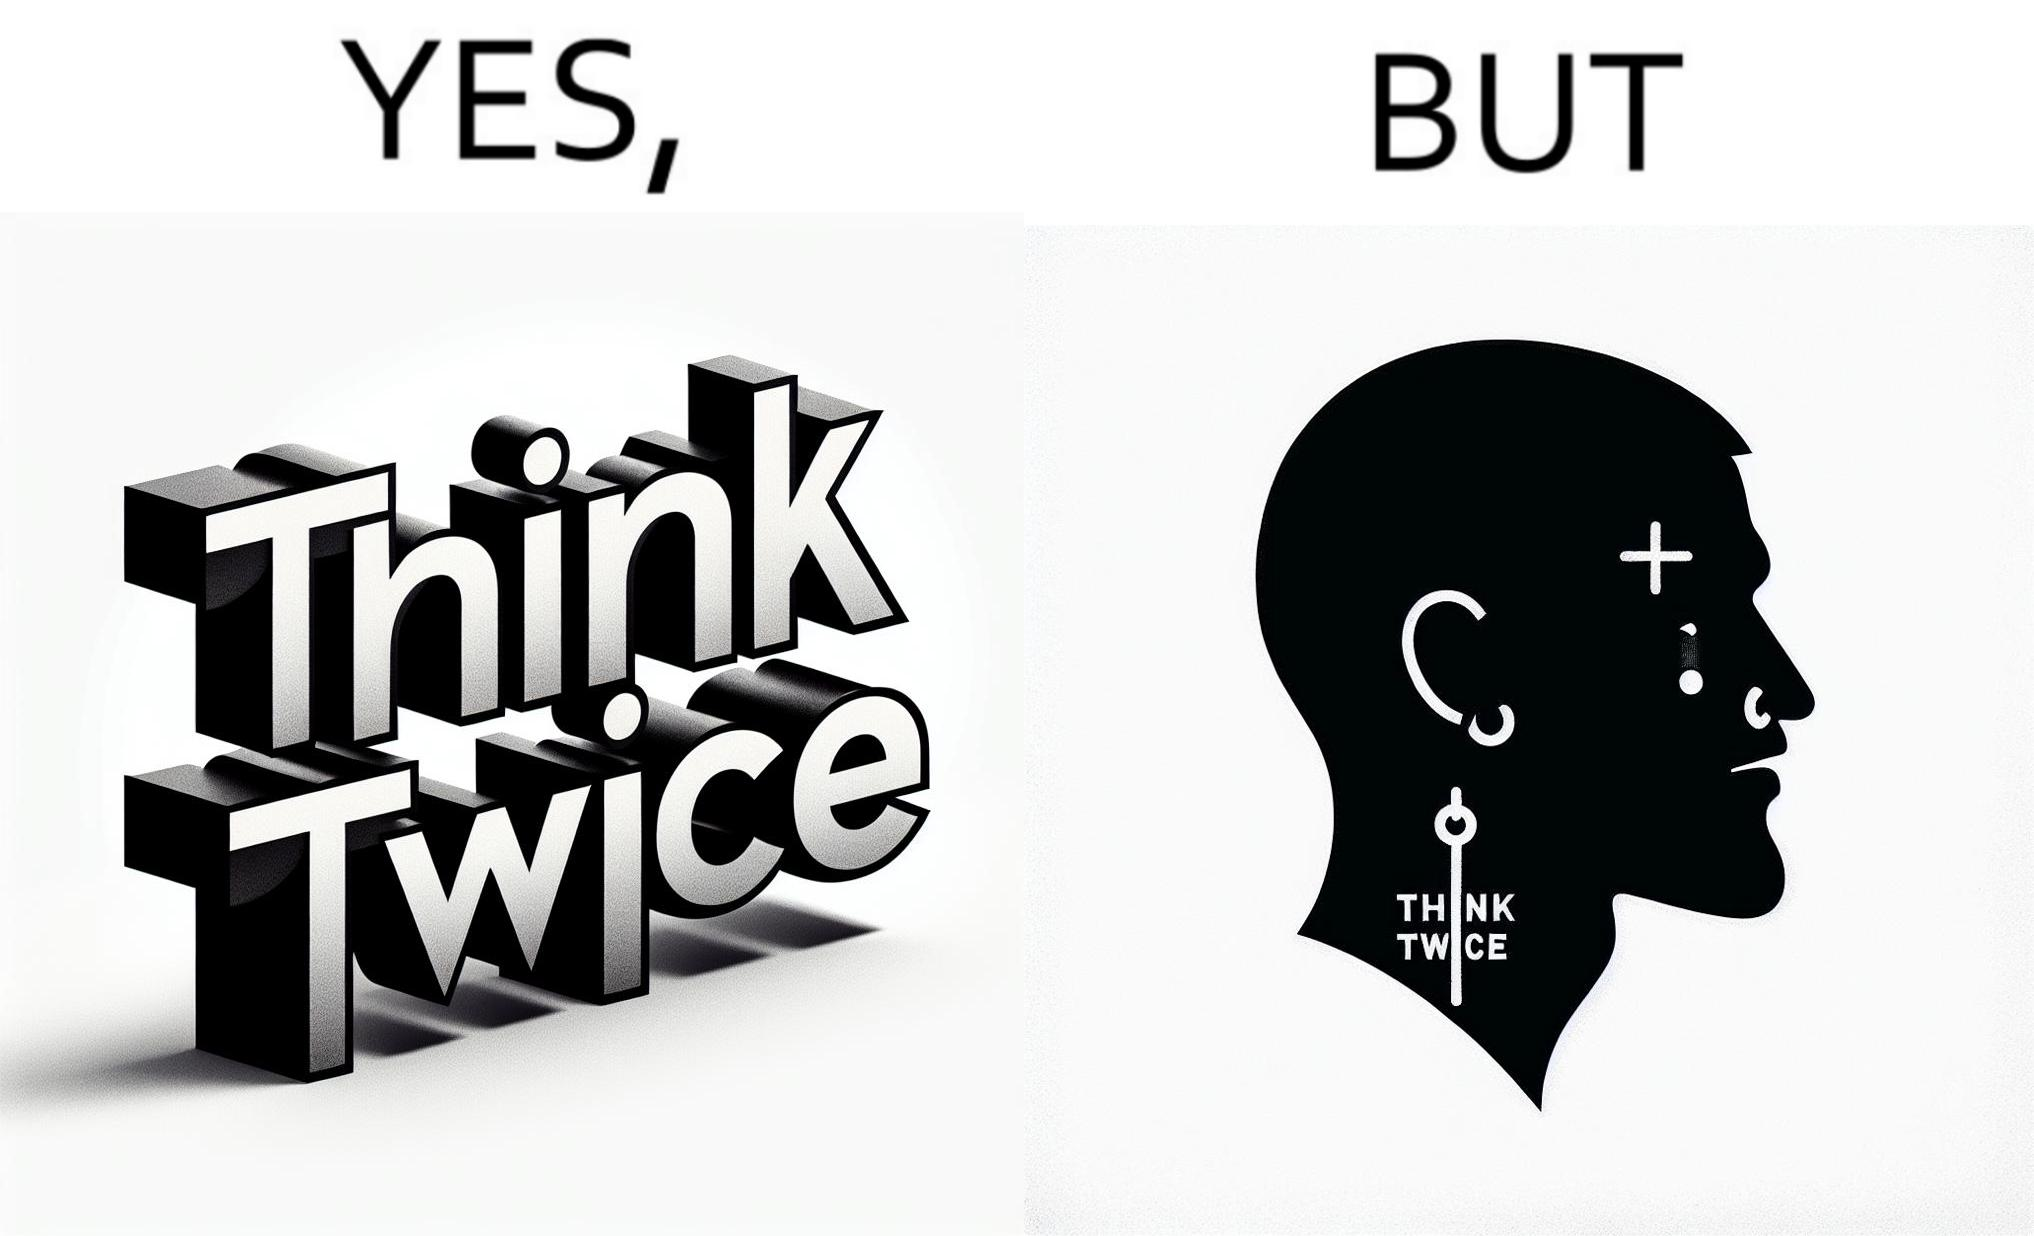Describe the satirical element in this image. The image is funny because even thought the tattoo on the face of the man says "think twice", the man did not think twice before getting the tattoo on his forehead. 